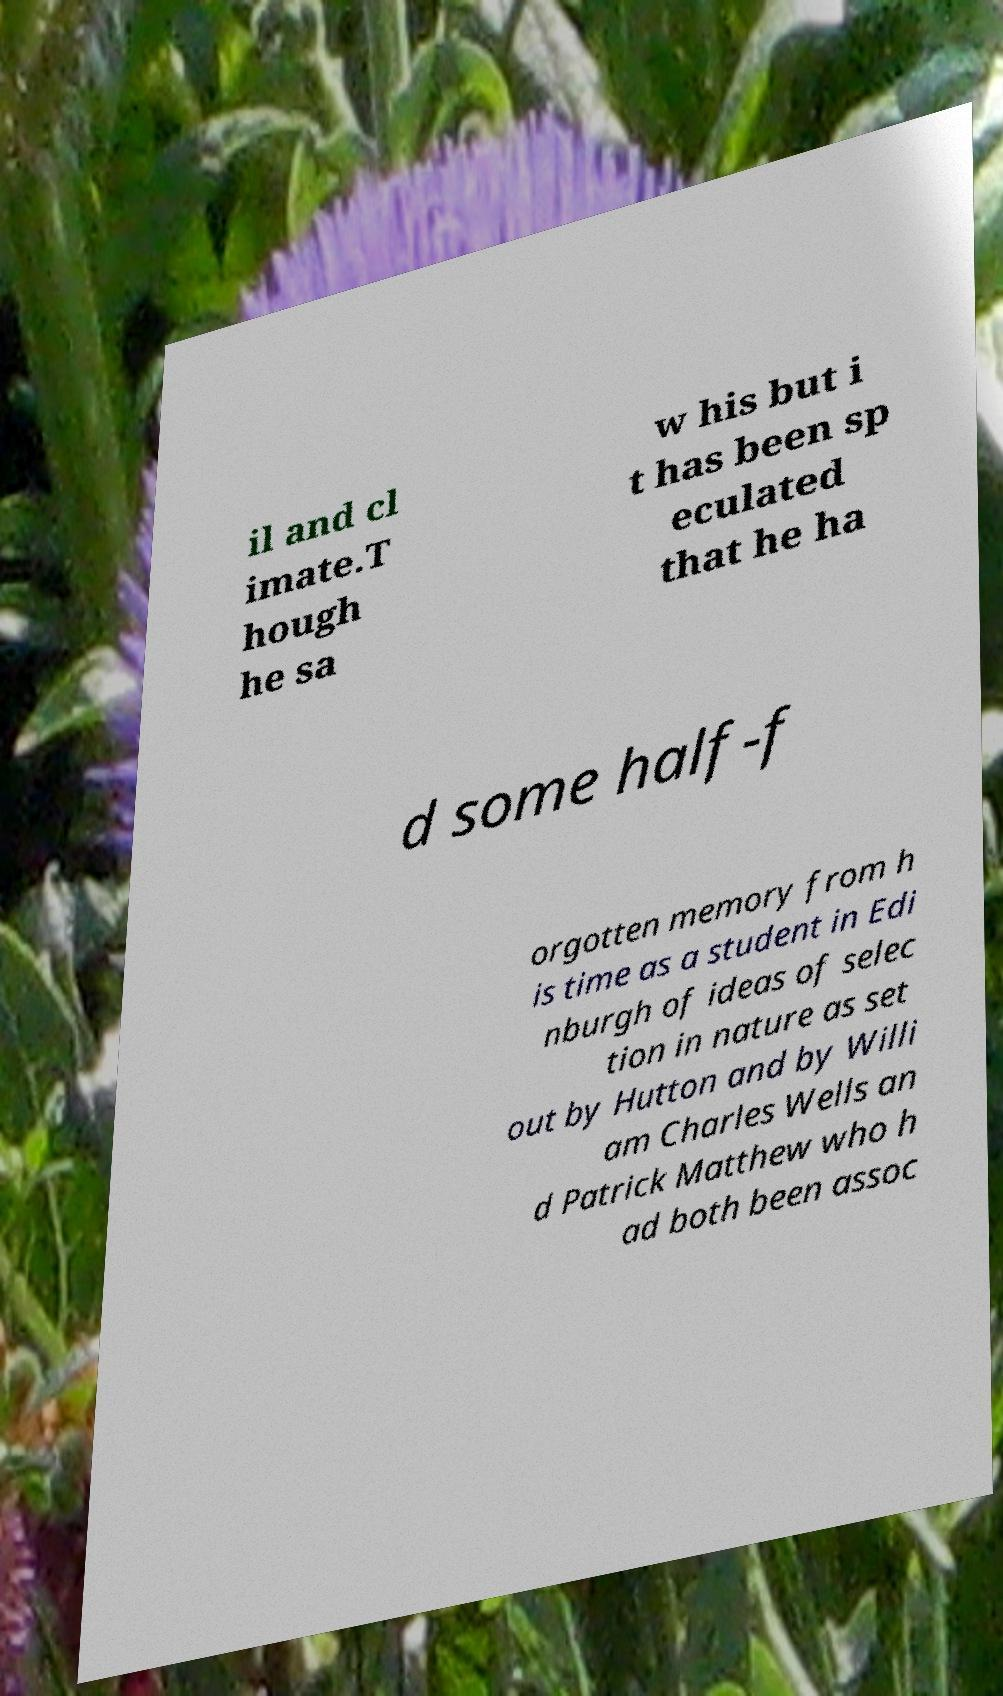Could you extract and type out the text from this image? il and cl imate.T hough he sa w his but i t has been sp eculated that he ha d some half-f orgotten memory from h is time as a student in Edi nburgh of ideas of selec tion in nature as set out by Hutton and by Willi am Charles Wells an d Patrick Matthew who h ad both been assoc 